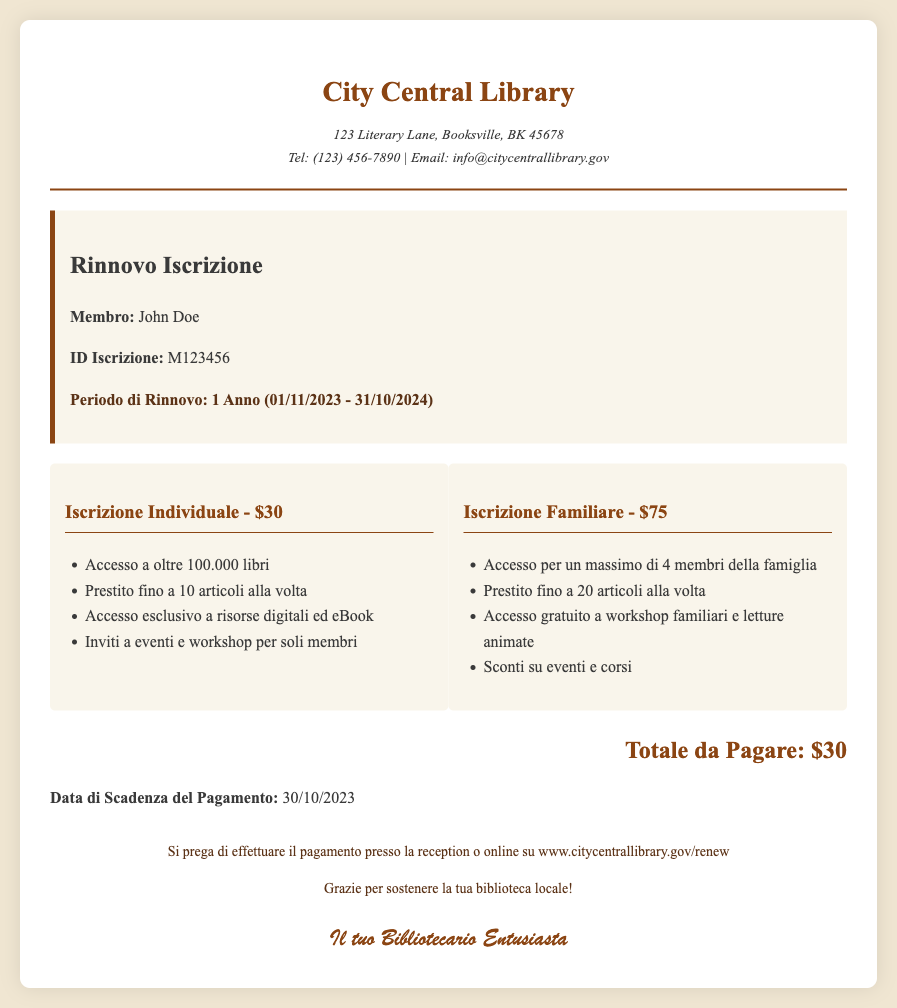What is the total fee for individual membership? The fee for individual membership is specifically stated in the document as $30.
Answer: $30 What is the renewal period for the membership? The renewal period is clearly mentioned in the document as 1 Year (01/11/2023 - 31/10/2024).
Answer: 1 Anno (01/11/2023 - 31/10/2024) How many items can be borrowed with a family membership? The document indicates that a family membership allows borrowing up to 20 items at a time.
Answer: 20 articoli What is the deadline for the payment? The payment deadline is provided in the document as 30/10/2023.
Answer: 30/10/2023 What is the main benefit of family membership? One of the benefits of family membership listed in the document is access for a maximum of 4 family members.
Answer: Access per un massimo di 4 membri della famiglia What type of events can individual members attend? The document mentions that individual members receive invitations to events and workshops exclusive to them.
Answer: Eventi e workshop per soli membri What is the total amount due for renewal? The total amount that needs to be paid for renewal is specified as $30 in the document.
Answer: $30 Where can the payment be made? The document outlines that payment can be made at the reception or online at the specified website.
Answer: www.citycentrallibrary.gov/renew 